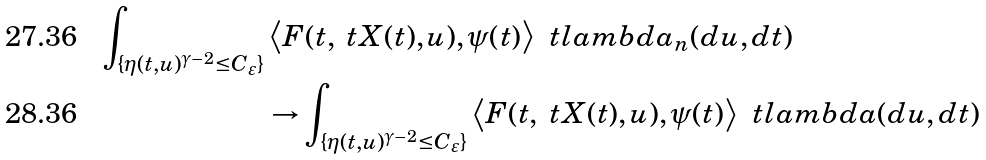<formula> <loc_0><loc_0><loc_500><loc_500>\int _ { \{ \eta ( t , u ) ^ { \gamma - 2 } \leq C _ { \varepsilon } \} } & \left \langle F ( t , \ t X ( t ) , u ) , \psi ( t ) \right \rangle \, \ t l a m b d a _ { n } ( d u , d t ) \\ & \to \int _ { \{ \eta ( t , u ) ^ { \gamma - 2 } \leq C _ { \varepsilon } \} } \left \langle F ( t , \ t X ( t ) , u ) , \psi ( t ) \right \rangle \, \ t l a m b d a ( d u , d t )</formula> 